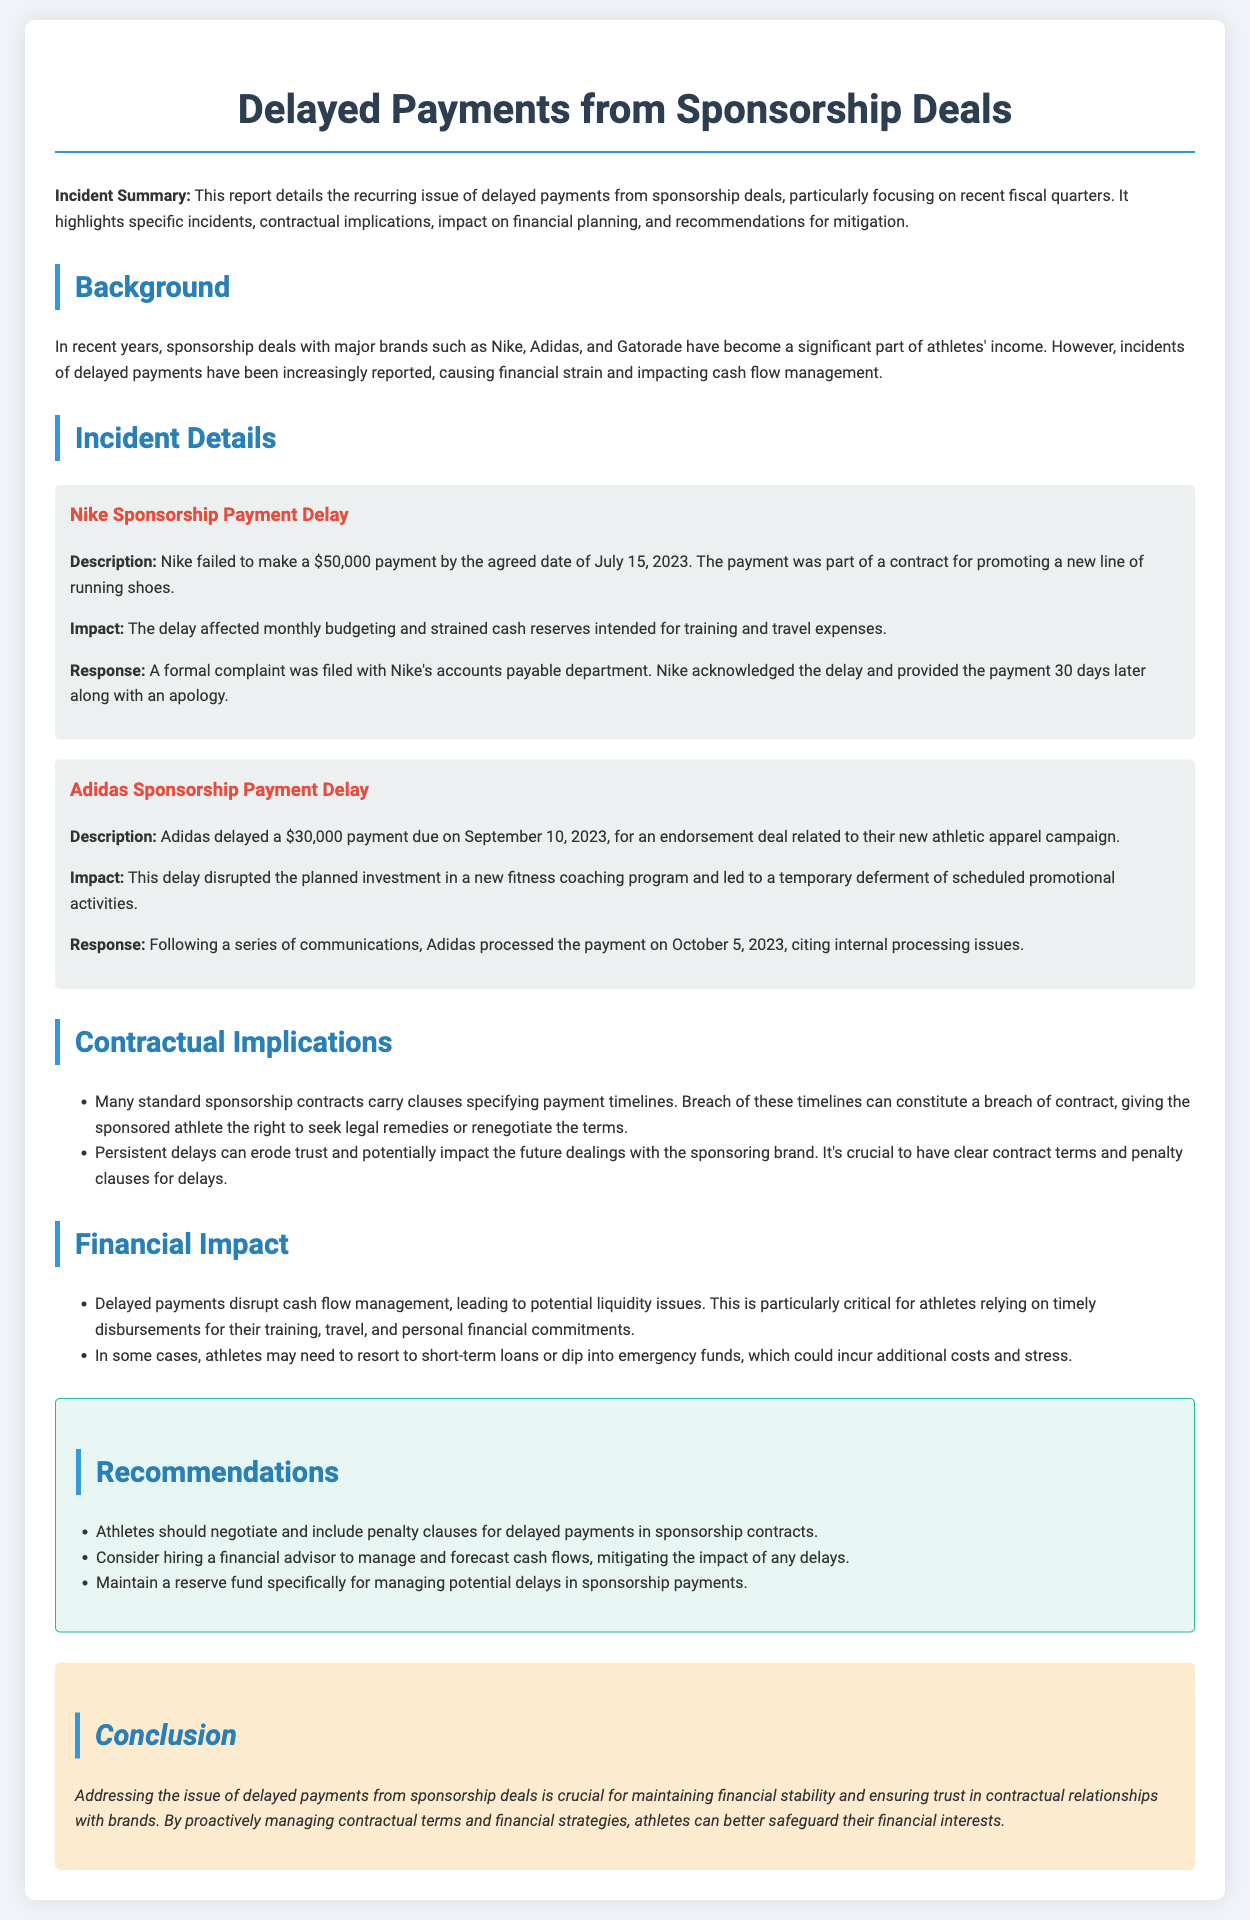What was the payment amount delayed by Nike? The document states that Nike failed to make a $50,000 payment.
Answer: $50,000 When was the payment from Adidas due? According to the document, the Adidas payment was due on September 10, 2023.
Answer: September 10, 2023 What was the total financial impact of delayed payments mentioned? The document highlights that delayed payments can lead to potential liquidity issues and reliance on short-term loans.
Answer: Liquidity issues How did Nike respond to the payment delay? The document mentions that Nike acknowledged the delay and provided the payment 30 days later along with an apology.
Answer: Acknowledgment and apology What should athletes include in their contracts to mitigate payment delays? The recommendations section states that athletes should negotiate and include penalty clauses for delayed payments in sponsorship contracts.
Answer: Penalty clauses What primary reason caused Adidas to delay the payment? The document explains that Adidas cited internal processing issues as the reason for the delay.
Answer: Internal processing issues What is a potential consequence of persistent payment delays? The document states that persistent delays can erode trust and potentially impact future dealings with the brand.
Answer: Erosion of trust What type of financial professional is recommended for athletes? The recommendations suggest athletes consider hiring a financial advisor to manage and forecast cash flows.
Answer: Financial advisor 